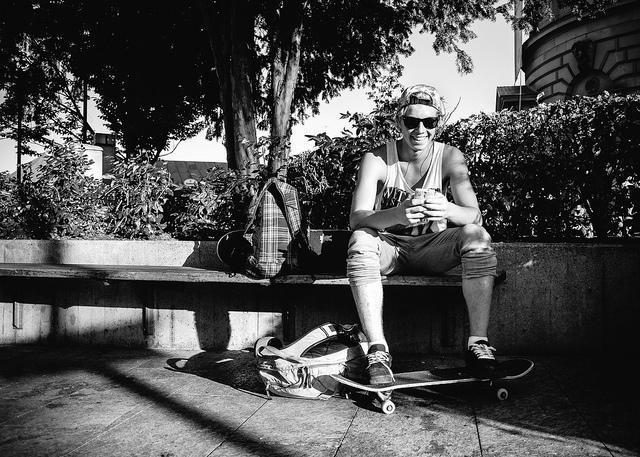How many people are sitting down?
Give a very brief answer. 1. How many benches can you see?
Give a very brief answer. 3. How many backpacks can you see?
Give a very brief answer. 2. How many skateboards are in the picture?
Give a very brief answer. 2. How many ski poles are to the right of the skier?
Give a very brief answer. 0. 